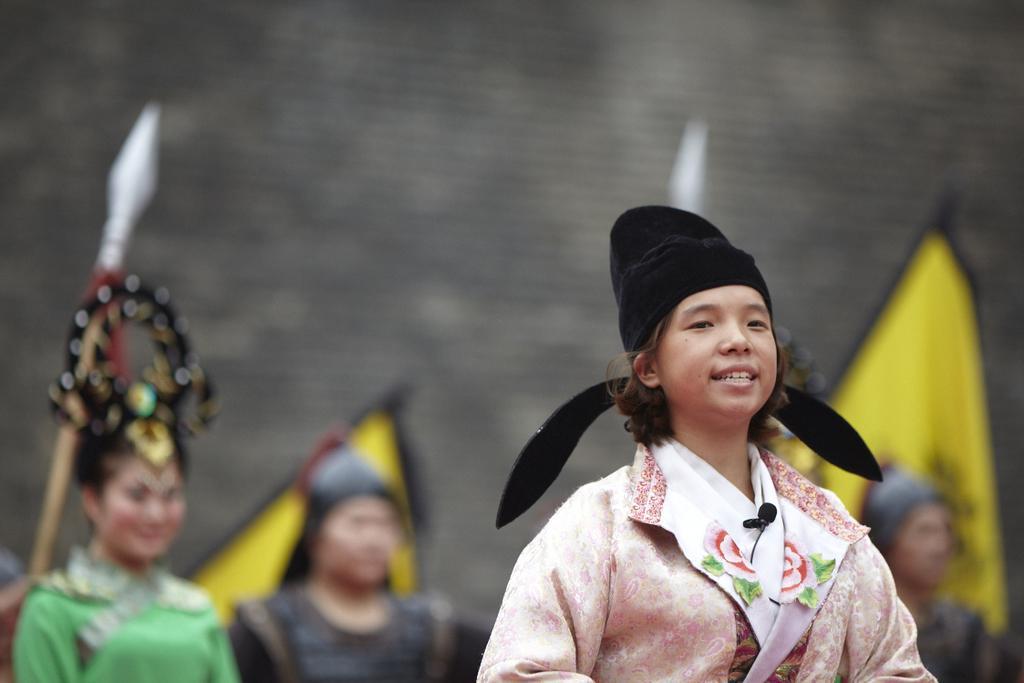How would you summarize this image in a sentence or two? In this picture we can see people wearing traditional dresses and are standing on the ground and looking at someone. In the background, we can see flags, weapons and a wall. 